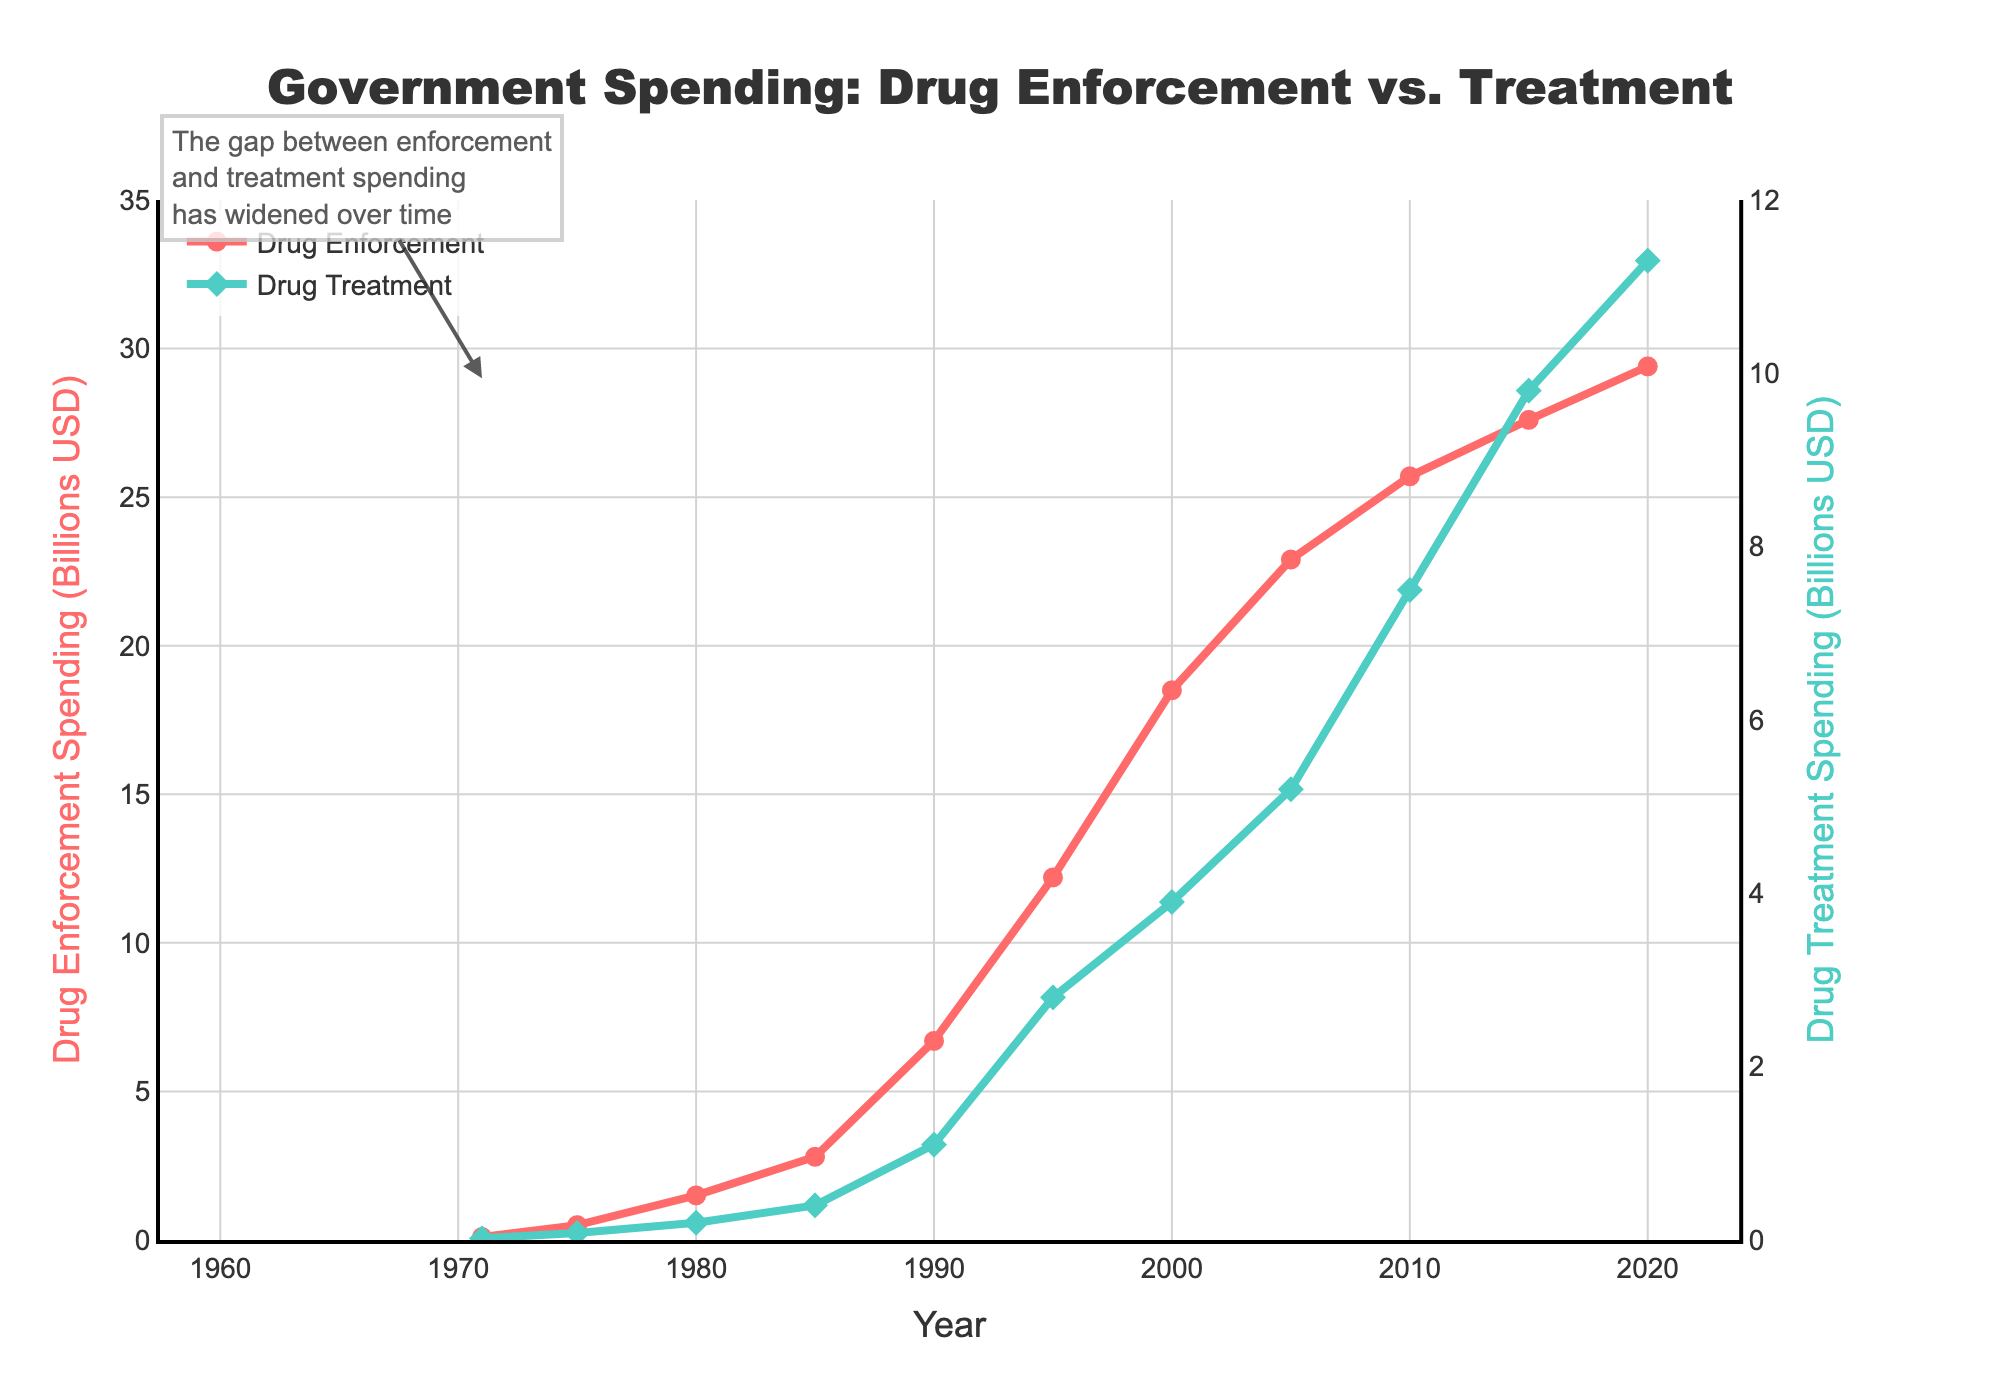What are the overall trends in government spending on drug enforcement and drug treatment from 1971 to 2020? The figure shows a consistent increase in both drug enforcement and drug treatment spending over time. Drug enforcement spending has grown significantly more than drug treatment, with a widened gap between the two.
Answer: Increased for both, larger increase for enforcement In which year did drug enforcement spending first exceed $10 billion? By looking at the red line representing drug enforcement spending, we see it crossing the $10 billion mark around 1995.
Answer: 1995 How much did the government spend on drug treatment programs in 2010, and how does it compare to the spending on drug enforcement that year? The teal line for drug treatment spending shows $7.5 billion in 2010. For drug enforcement, the red line shows $25.7 billion. Comparison: $7.5 billion in treatment vs. $25.7 billion in enforcement.
Answer: $7.5 billion treatment, $25.7 billion enforcement What is the difference between drug enforcement and drug treatment spending in 1990? In 1990, drug enforcement spending was $6.7 billion and drug treatment spending was $1.1 billion. The difference is $6.7 billion - $1.1 billion = $5.6 billion.
Answer: $5.6 billion Which year saw the highest increase in drug enforcement spending? The figure shows steep increases by observing the slope of the red line; the sharpest increase is between 1980 and 1990.
Answer: 1980-1990 By what factor did drug enforcement spending increase from 1971 to 2020? Drug enforcement spending in 1971 was $0.1 billion, and in 2020 it was $29.4 billion. The factor of increase is $29.4 billion / $0.1 billion = 294.
Answer: 294 How does the rate of increase in drug treatment spending compare to drug enforcement spending between 1971 and 2020? Both spending categories increased, but the red line for drug enforcement shows a much steeper increase compared to the teal line for drug treatment, indicating a faster rate of increase for enforcement.
Answer: Faster for enforcement In which decade did drug treatment spending experience the highest growth? Observing the teal line, the steepest increase occurs from 2000 to 2010, indicating the highest growth in that decade.
Answer: 2000-2010 What can you infer about the government’s priorities over the years based on the spending trends shown in the figure? The substantial increase in drug enforcement spending compared to drug treatment suggests a higher priority on enforcement. The widening gap signifies a stronger focus on enforcement over treatment.
Answer: Higher priority on enforcement 